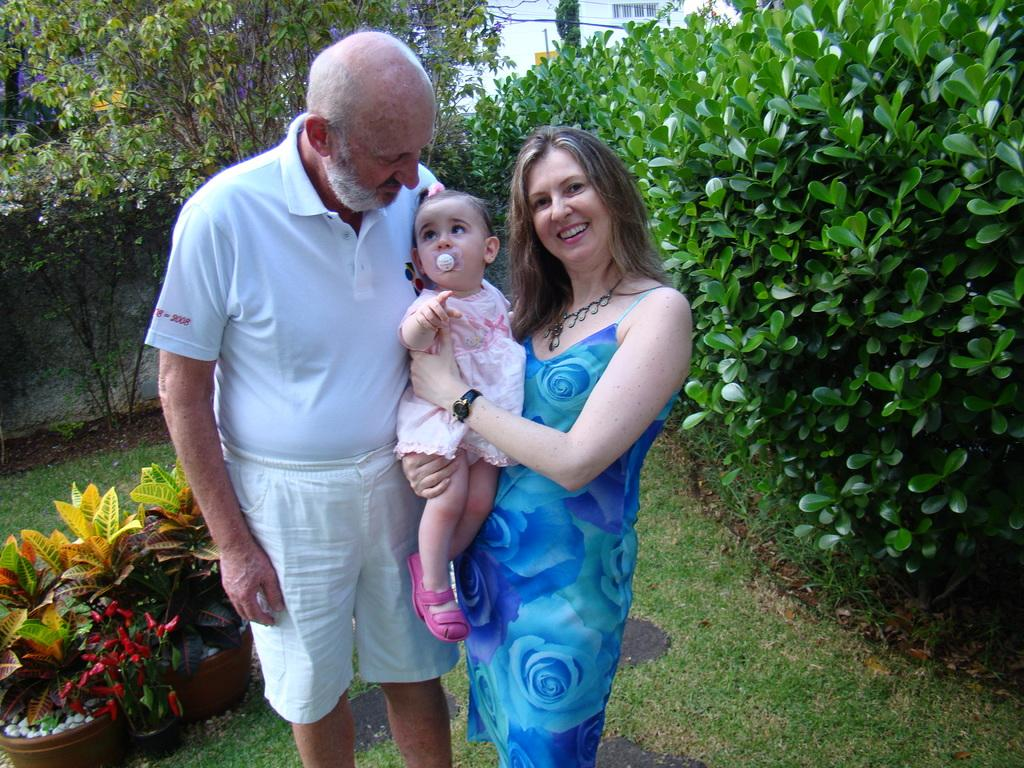How many people are present in the image? There are two people standing in the image. What is the woman holding in the image? The woman is holding a baby. What can be seen in the background of the image? There are plants, trees, and a wall in the background of the image. What type of wine is being served in the image? There is no wine present in the image; it features two people standing and a woman holding a baby. How many trucks can be seen in the image? There are no trucks visible in the image. 